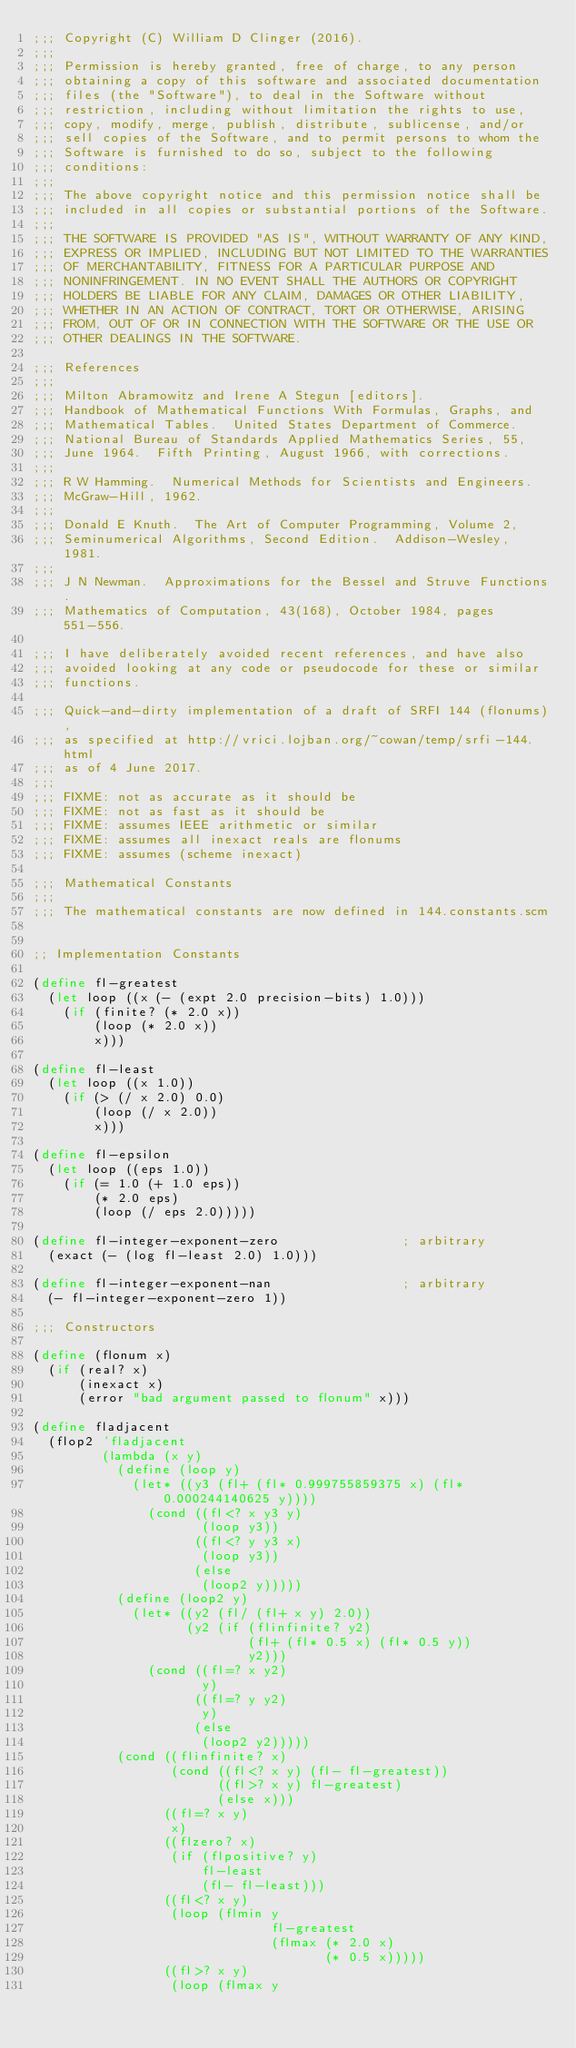Convert code to text. <code><loc_0><loc_0><loc_500><loc_500><_Scheme_>;;; Copyright (C) William D Clinger (2016).
;;; 
;;; Permission is hereby granted, free of charge, to any person
;;; obtaining a copy of this software and associated documentation
;;; files (the "Software"), to deal in the Software without
;;; restriction, including without limitation the rights to use,
;;; copy, modify, merge, publish, distribute, sublicense, and/or
;;; sell copies of the Software, and to permit persons to whom the
;;; Software is furnished to do so, subject to the following
;;; conditions:
;;; 
;;; The above copyright notice and this permission notice shall be
;;; included in all copies or substantial portions of the Software.
;;; 
;;; THE SOFTWARE IS PROVIDED "AS IS", WITHOUT WARRANTY OF ANY KIND,
;;; EXPRESS OR IMPLIED, INCLUDING BUT NOT LIMITED TO THE WARRANTIES
;;; OF MERCHANTABILITY, FITNESS FOR A PARTICULAR PURPOSE AND
;;; NONINFRINGEMENT. IN NO EVENT SHALL THE AUTHORS OR COPYRIGHT
;;; HOLDERS BE LIABLE FOR ANY CLAIM, DAMAGES OR OTHER LIABILITY,
;;; WHETHER IN AN ACTION OF CONTRACT, TORT OR OTHERWISE, ARISING
;;; FROM, OUT OF OR IN CONNECTION WITH THE SOFTWARE OR THE USE OR
;;; OTHER DEALINGS IN THE SOFTWARE. 

;;; References
;;;
;;; Milton Abramowitz and Irene A Stegun [editors].
;;; Handbook of Mathematical Functions With Formulas, Graphs, and
;;; Mathematical Tables.  United States Department of Commerce.
;;; National Bureau of Standards Applied Mathematics Series, 55,
;;; June 1964.  Fifth Printing, August 1966, with corrections.
;;;
;;; R W Hamming.  Numerical Methods for Scientists and Engineers.
;;; McGraw-Hill, 1962.
;;;
;;; Donald E Knuth.  The Art of Computer Programming, Volume 2,
;;; Seminumerical Algorithms, Second Edition.  Addison-Wesley, 1981.
;;;
;;; J N Newman.  Approximations for the Bessel and Struve Functions.
;;; Mathematics of Computation, 43(168), October 1984, pages 551-556.

;;; I have deliberately avoided recent references, and have also
;;; avoided looking at any code or pseudocode for these or similar
;;; functions.

;;; Quick-and-dirty implementation of a draft of SRFI 144 (flonums),
;;; as specified at http://vrici.lojban.org/~cowan/temp/srfi-144.html
;;; as of 4 June 2017.
;;;
;;; FIXME: not as accurate as it should be
;;; FIXME: not as fast as it should be
;;; FIXME: assumes IEEE arithmetic or similar
;;; FIXME: assumes all inexact reals are flonums
;;; FIXME: assumes (scheme inexact)

;;; Mathematical Constants
;;;
;;; The mathematical constants are now defined in 144.constants.scm


;; Implementation Constants

(define fl-greatest
  (let loop ((x (- (expt 2.0 precision-bits) 1.0)))
    (if (finite? (* 2.0 x))
        (loop (* 2.0 x))
        x)))

(define fl-least
  (let loop ((x 1.0))
    (if (> (/ x 2.0) 0.0)
        (loop (/ x 2.0))
        x)))

(define fl-epsilon
  (let loop ((eps 1.0))
    (if (= 1.0 (+ 1.0 eps))
        (* 2.0 eps)
        (loop (/ eps 2.0)))))

(define fl-integer-exponent-zero                ; arbitrary
  (exact (- (log fl-least 2.0) 1.0)))

(define fl-integer-exponent-nan                 ; arbitrary
  (- fl-integer-exponent-zero 1))

;;; Constructors

(define (flonum x)
  (if (real? x)
      (inexact x)
      (error "bad argument passed to flonum" x)))

(define fladjacent
  (flop2 'fladjacent
         (lambda (x y)
           (define (loop y)
             (let* ((y3 (fl+ (fl* 0.999755859375 x) (fl* 0.000244140625 y))))
               (cond ((fl<? x y3 y)
                      (loop y3))
                     ((fl<? y y3 x)
                      (loop y3))
                     (else
                      (loop2 y)))))
           (define (loop2 y)
             (let* ((y2 (fl/ (fl+ x y) 2.0))
                    (y2 (if (flinfinite? y2)
                            (fl+ (fl* 0.5 x) (fl* 0.5 y))
                            y2)))
               (cond ((fl=? x y2)
                      y)
                     ((fl=? y y2)
                      y)
                     (else
                      (loop2 y2)))))
           (cond ((flinfinite? x)
                  (cond ((fl<? x y) (fl- fl-greatest))
                        ((fl>? x y) fl-greatest)
                        (else x)))
                 ((fl=? x y)
                  x)
                 ((flzero? x)
                  (if (flpositive? y)
                      fl-least
                      (fl- fl-least)))
                 ((fl<? x y)
                  (loop (flmin y
                               fl-greatest
                               (flmax (* 2.0 x)
                                      (* 0.5 x)))))
                 ((fl>? x y)
                  (loop (flmax y</code> 